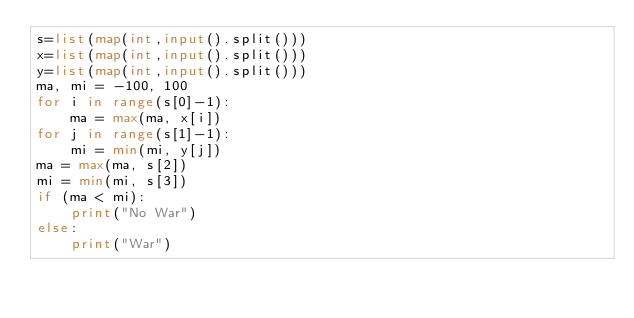Convert code to text. <code><loc_0><loc_0><loc_500><loc_500><_Python_>s=list(map(int,input().split()))
x=list(map(int,input().split()))
y=list(map(int,input().split()))
ma, mi = -100, 100
for i in range(s[0]-1):
    ma = max(ma, x[i])
for j in range(s[1]-1):
    mi = min(mi, y[j])
ma = max(ma, s[2])
mi = min(mi, s[3])
if (ma < mi):
    print("No War")
else:
    print("War")</code> 